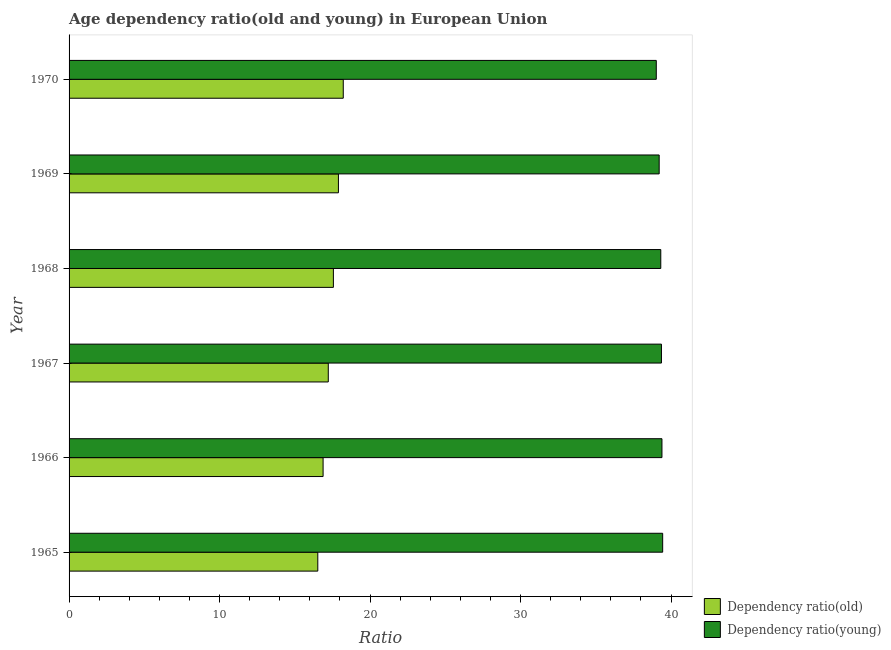How many different coloured bars are there?
Give a very brief answer. 2. How many groups of bars are there?
Offer a very short reply. 6. Are the number of bars per tick equal to the number of legend labels?
Keep it short and to the point. Yes. What is the label of the 4th group of bars from the top?
Keep it short and to the point. 1967. In how many cases, is the number of bars for a given year not equal to the number of legend labels?
Provide a succinct answer. 0. What is the age dependency ratio(old) in 1966?
Offer a terse response. 16.88. Across all years, what is the maximum age dependency ratio(young)?
Your answer should be very brief. 39.44. Across all years, what is the minimum age dependency ratio(old)?
Provide a succinct answer. 16.53. In which year was the age dependency ratio(young) maximum?
Your answer should be compact. 1965. In which year was the age dependency ratio(old) minimum?
Your answer should be compact. 1965. What is the total age dependency ratio(old) in the graph?
Keep it short and to the point. 104.31. What is the difference between the age dependency ratio(old) in 1966 and that in 1969?
Your response must be concise. -1.02. What is the difference between the age dependency ratio(young) in 1967 and the age dependency ratio(old) in 1965?
Offer a very short reply. 22.83. What is the average age dependency ratio(young) per year?
Offer a terse response. 39.29. In the year 1967, what is the difference between the age dependency ratio(old) and age dependency ratio(young)?
Offer a very short reply. -22.14. In how many years, is the age dependency ratio(young) greater than 34 ?
Keep it short and to the point. 6. Is the age dependency ratio(old) in 1965 less than that in 1970?
Give a very brief answer. Yes. What is the difference between the highest and the second highest age dependency ratio(old)?
Provide a succinct answer. 0.32. What is the difference between the highest and the lowest age dependency ratio(young)?
Offer a very short reply. 0.42. In how many years, is the age dependency ratio(old) greater than the average age dependency ratio(old) taken over all years?
Keep it short and to the point. 3. What does the 2nd bar from the top in 1970 represents?
Give a very brief answer. Dependency ratio(old). What does the 1st bar from the bottom in 1967 represents?
Your answer should be very brief. Dependency ratio(old). How many bars are there?
Offer a very short reply. 12. Are all the bars in the graph horizontal?
Give a very brief answer. Yes. How many years are there in the graph?
Offer a terse response. 6. What is the difference between two consecutive major ticks on the X-axis?
Keep it short and to the point. 10. Are the values on the major ticks of X-axis written in scientific E-notation?
Keep it short and to the point. No. Does the graph contain any zero values?
Give a very brief answer. No. How many legend labels are there?
Offer a very short reply. 2. What is the title of the graph?
Make the answer very short. Age dependency ratio(old and young) in European Union. What is the label or title of the X-axis?
Offer a very short reply. Ratio. What is the label or title of the Y-axis?
Your answer should be compact. Year. What is the Ratio in Dependency ratio(old) in 1965?
Ensure brevity in your answer.  16.53. What is the Ratio in Dependency ratio(young) in 1965?
Your answer should be compact. 39.44. What is the Ratio in Dependency ratio(old) in 1966?
Keep it short and to the point. 16.88. What is the Ratio in Dependency ratio(young) in 1966?
Your response must be concise. 39.39. What is the Ratio of Dependency ratio(old) in 1967?
Give a very brief answer. 17.22. What is the Ratio in Dependency ratio(young) in 1967?
Provide a short and direct response. 39.36. What is the Ratio of Dependency ratio(old) in 1968?
Provide a short and direct response. 17.56. What is the Ratio of Dependency ratio(young) in 1968?
Offer a very short reply. 39.32. What is the Ratio in Dependency ratio(old) in 1969?
Keep it short and to the point. 17.9. What is the Ratio in Dependency ratio(young) in 1969?
Your response must be concise. 39.21. What is the Ratio in Dependency ratio(old) in 1970?
Provide a short and direct response. 18.22. What is the Ratio in Dependency ratio(young) in 1970?
Make the answer very short. 39.02. Across all years, what is the maximum Ratio of Dependency ratio(old)?
Your answer should be compact. 18.22. Across all years, what is the maximum Ratio in Dependency ratio(young)?
Keep it short and to the point. 39.44. Across all years, what is the minimum Ratio in Dependency ratio(old)?
Keep it short and to the point. 16.53. Across all years, what is the minimum Ratio of Dependency ratio(young)?
Give a very brief answer. 39.02. What is the total Ratio of Dependency ratio(old) in the graph?
Provide a short and direct response. 104.31. What is the total Ratio of Dependency ratio(young) in the graph?
Give a very brief answer. 235.74. What is the difference between the Ratio of Dependency ratio(old) in 1965 and that in 1966?
Provide a short and direct response. -0.35. What is the difference between the Ratio of Dependency ratio(young) in 1965 and that in 1966?
Your response must be concise. 0.05. What is the difference between the Ratio of Dependency ratio(old) in 1965 and that in 1967?
Make the answer very short. -0.7. What is the difference between the Ratio of Dependency ratio(young) in 1965 and that in 1967?
Give a very brief answer. 0.08. What is the difference between the Ratio of Dependency ratio(old) in 1965 and that in 1968?
Make the answer very short. -1.04. What is the difference between the Ratio of Dependency ratio(young) in 1965 and that in 1968?
Your response must be concise. 0.13. What is the difference between the Ratio of Dependency ratio(old) in 1965 and that in 1969?
Provide a succinct answer. -1.37. What is the difference between the Ratio in Dependency ratio(young) in 1965 and that in 1969?
Offer a terse response. 0.23. What is the difference between the Ratio of Dependency ratio(old) in 1965 and that in 1970?
Keep it short and to the point. -1.69. What is the difference between the Ratio in Dependency ratio(young) in 1965 and that in 1970?
Your answer should be compact. 0.42. What is the difference between the Ratio of Dependency ratio(old) in 1966 and that in 1967?
Make the answer very short. -0.34. What is the difference between the Ratio in Dependency ratio(young) in 1966 and that in 1967?
Give a very brief answer. 0.03. What is the difference between the Ratio of Dependency ratio(old) in 1966 and that in 1968?
Provide a succinct answer. -0.68. What is the difference between the Ratio of Dependency ratio(young) in 1966 and that in 1968?
Keep it short and to the point. 0.08. What is the difference between the Ratio of Dependency ratio(old) in 1966 and that in 1969?
Your answer should be very brief. -1.02. What is the difference between the Ratio in Dependency ratio(young) in 1966 and that in 1969?
Your answer should be very brief. 0.19. What is the difference between the Ratio of Dependency ratio(old) in 1966 and that in 1970?
Keep it short and to the point. -1.34. What is the difference between the Ratio in Dependency ratio(young) in 1966 and that in 1970?
Your response must be concise. 0.38. What is the difference between the Ratio in Dependency ratio(old) in 1967 and that in 1968?
Give a very brief answer. -0.34. What is the difference between the Ratio in Dependency ratio(young) in 1967 and that in 1968?
Ensure brevity in your answer.  0.04. What is the difference between the Ratio in Dependency ratio(old) in 1967 and that in 1969?
Your answer should be compact. -0.67. What is the difference between the Ratio in Dependency ratio(young) in 1967 and that in 1969?
Give a very brief answer. 0.15. What is the difference between the Ratio of Dependency ratio(old) in 1967 and that in 1970?
Ensure brevity in your answer.  -1. What is the difference between the Ratio in Dependency ratio(young) in 1967 and that in 1970?
Your response must be concise. 0.34. What is the difference between the Ratio of Dependency ratio(old) in 1968 and that in 1969?
Offer a terse response. -0.33. What is the difference between the Ratio in Dependency ratio(young) in 1968 and that in 1969?
Your response must be concise. 0.11. What is the difference between the Ratio in Dependency ratio(old) in 1968 and that in 1970?
Your answer should be very brief. -0.66. What is the difference between the Ratio of Dependency ratio(young) in 1968 and that in 1970?
Your answer should be very brief. 0.3. What is the difference between the Ratio in Dependency ratio(old) in 1969 and that in 1970?
Your answer should be compact. -0.32. What is the difference between the Ratio of Dependency ratio(young) in 1969 and that in 1970?
Offer a terse response. 0.19. What is the difference between the Ratio in Dependency ratio(old) in 1965 and the Ratio in Dependency ratio(young) in 1966?
Keep it short and to the point. -22.87. What is the difference between the Ratio in Dependency ratio(old) in 1965 and the Ratio in Dependency ratio(young) in 1967?
Offer a terse response. -22.83. What is the difference between the Ratio of Dependency ratio(old) in 1965 and the Ratio of Dependency ratio(young) in 1968?
Provide a short and direct response. -22.79. What is the difference between the Ratio in Dependency ratio(old) in 1965 and the Ratio in Dependency ratio(young) in 1969?
Provide a succinct answer. -22.68. What is the difference between the Ratio in Dependency ratio(old) in 1965 and the Ratio in Dependency ratio(young) in 1970?
Your answer should be compact. -22.49. What is the difference between the Ratio in Dependency ratio(old) in 1966 and the Ratio in Dependency ratio(young) in 1967?
Offer a very short reply. -22.48. What is the difference between the Ratio of Dependency ratio(old) in 1966 and the Ratio of Dependency ratio(young) in 1968?
Provide a succinct answer. -22.44. What is the difference between the Ratio of Dependency ratio(old) in 1966 and the Ratio of Dependency ratio(young) in 1969?
Offer a very short reply. -22.33. What is the difference between the Ratio in Dependency ratio(old) in 1966 and the Ratio in Dependency ratio(young) in 1970?
Your answer should be very brief. -22.14. What is the difference between the Ratio of Dependency ratio(old) in 1967 and the Ratio of Dependency ratio(young) in 1968?
Offer a terse response. -22.09. What is the difference between the Ratio in Dependency ratio(old) in 1967 and the Ratio in Dependency ratio(young) in 1969?
Your answer should be compact. -21.99. What is the difference between the Ratio in Dependency ratio(old) in 1967 and the Ratio in Dependency ratio(young) in 1970?
Keep it short and to the point. -21.79. What is the difference between the Ratio in Dependency ratio(old) in 1968 and the Ratio in Dependency ratio(young) in 1969?
Provide a short and direct response. -21.65. What is the difference between the Ratio of Dependency ratio(old) in 1968 and the Ratio of Dependency ratio(young) in 1970?
Provide a short and direct response. -21.45. What is the difference between the Ratio of Dependency ratio(old) in 1969 and the Ratio of Dependency ratio(young) in 1970?
Give a very brief answer. -21.12. What is the average Ratio of Dependency ratio(old) per year?
Offer a very short reply. 17.38. What is the average Ratio in Dependency ratio(young) per year?
Keep it short and to the point. 39.29. In the year 1965, what is the difference between the Ratio of Dependency ratio(old) and Ratio of Dependency ratio(young)?
Your answer should be compact. -22.91. In the year 1966, what is the difference between the Ratio of Dependency ratio(old) and Ratio of Dependency ratio(young)?
Ensure brevity in your answer.  -22.52. In the year 1967, what is the difference between the Ratio of Dependency ratio(old) and Ratio of Dependency ratio(young)?
Make the answer very short. -22.14. In the year 1968, what is the difference between the Ratio of Dependency ratio(old) and Ratio of Dependency ratio(young)?
Make the answer very short. -21.75. In the year 1969, what is the difference between the Ratio in Dependency ratio(old) and Ratio in Dependency ratio(young)?
Keep it short and to the point. -21.31. In the year 1970, what is the difference between the Ratio in Dependency ratio(old) and Ratio in Dependency ratio(young)?
Offer a very short reply. -20.8. What is the ratio of the Ratio in Dependency ratio(old) in 1965 to that in 1966?
Offer a terse response. 0.98. What is the ratio of the Ratio in Dependency ratio(old) in 1965 to that in 1967?
Provide a succinct answer. 0.96. What is the ratio of the Ratio of Dependency ratio(old) in 1965 to that in 1968?
Provide a short and direct response. 0.94. What is the ratio of the Ratio of Dependency ratio(old) in 1965 to that in 1969?
Your answer should be compact. 0.92. What is the ratio of the Ratio of Dependency ratio(young) in 1965 to that in 1969?
Your response must be concise. 1.01. What is the ratio of the Ratio in Dependency ratio(old) in 1965 to that in 1970?
Provide a short and direct response. 0.91. What is the ratio of the Ratio of Dependency ratio(young) in 1965 to that in 1970?
Offer a terse response. 1.01. What is the ratio of the Ratio in Dependency ratio(old) in 1966 to that in 1967?
Your answer should be very brief. 0.98. What is the ratio of the Ratio in Dependency ratio(old) in 1966 to that in 1968?
Keep it short and to the point. 0.96. What is the ratio of the Ratio of Dependency ratio(old) in 1966 to that in 1969?
Offer a very short reply. 0.94. What is the ratio of the Ratio of Dependency ratio(young) in 1966 to that in 1969?
Make the answer very short. 1. What is the ratio of the Ratio in Dependency ratio(old) in 1966 to that in 1970?
Keep it short and to the point. 0.93. What is the ratio of the Ratio in Dependency ratio(young) in 1966 to that in 1970?
Keep it short and to the point. 1.01. What is the ratio of the Ratio in Dependency ratio(old) in 1967 to that in 1968?
Offer a very short reply. 0.98. What is the ratio of the Ratio in Dependency ratio(young) in 1967 to that in 1968?
Offer a terse response. 1. What is the ratio of the Ratio of Dependency ratio(old) in 1967 to that in 1969?
Your answer should be compact. 0.96. What is the ratio of the Ratio of Dependency ratio(old) in 1967 to that in 1970?
Give a very brief answer. 0.95. What is the ratio of the Ratio in Dependency ratio(young) in 1967 to that in 1970?
Offer a terse response. 1.01. What is the ratio of the Ratio of Dependency ratio(old) in 1968 to that in 1969?
Ensure brevity in your answer.  0.98. What is the ratio of the Ratio of Dependency ratio(young) in 1968 to that in 1970?
Your answer should be very brief. 1.01. What is the ratio of the Ratio of Dependency ratio(old) in 1969 to that in 1970?
Provide a short and direct response. 0.98. What is the ratio of the Ratio in Dependency ratio(young) in 1969 to that in 1970?
Keep it short and to the point. 1. What is the difference between the highest and the second highest Ratio of Dependency ratio(old)?
Provide a short and direct response. 0.32. What is the difference between the highest and the second highest Ratio in Dependency ratio(young)?
Keep it short and to the point. 0.05. What is the difference between the highest and the lowest Ratio of Dependency ratio(old)?
Offer a terse response. 1.69. What is the difference between the highest and the lowest Ratio of Dependency ratio(young)?
Make the answer very short. 0.42. 